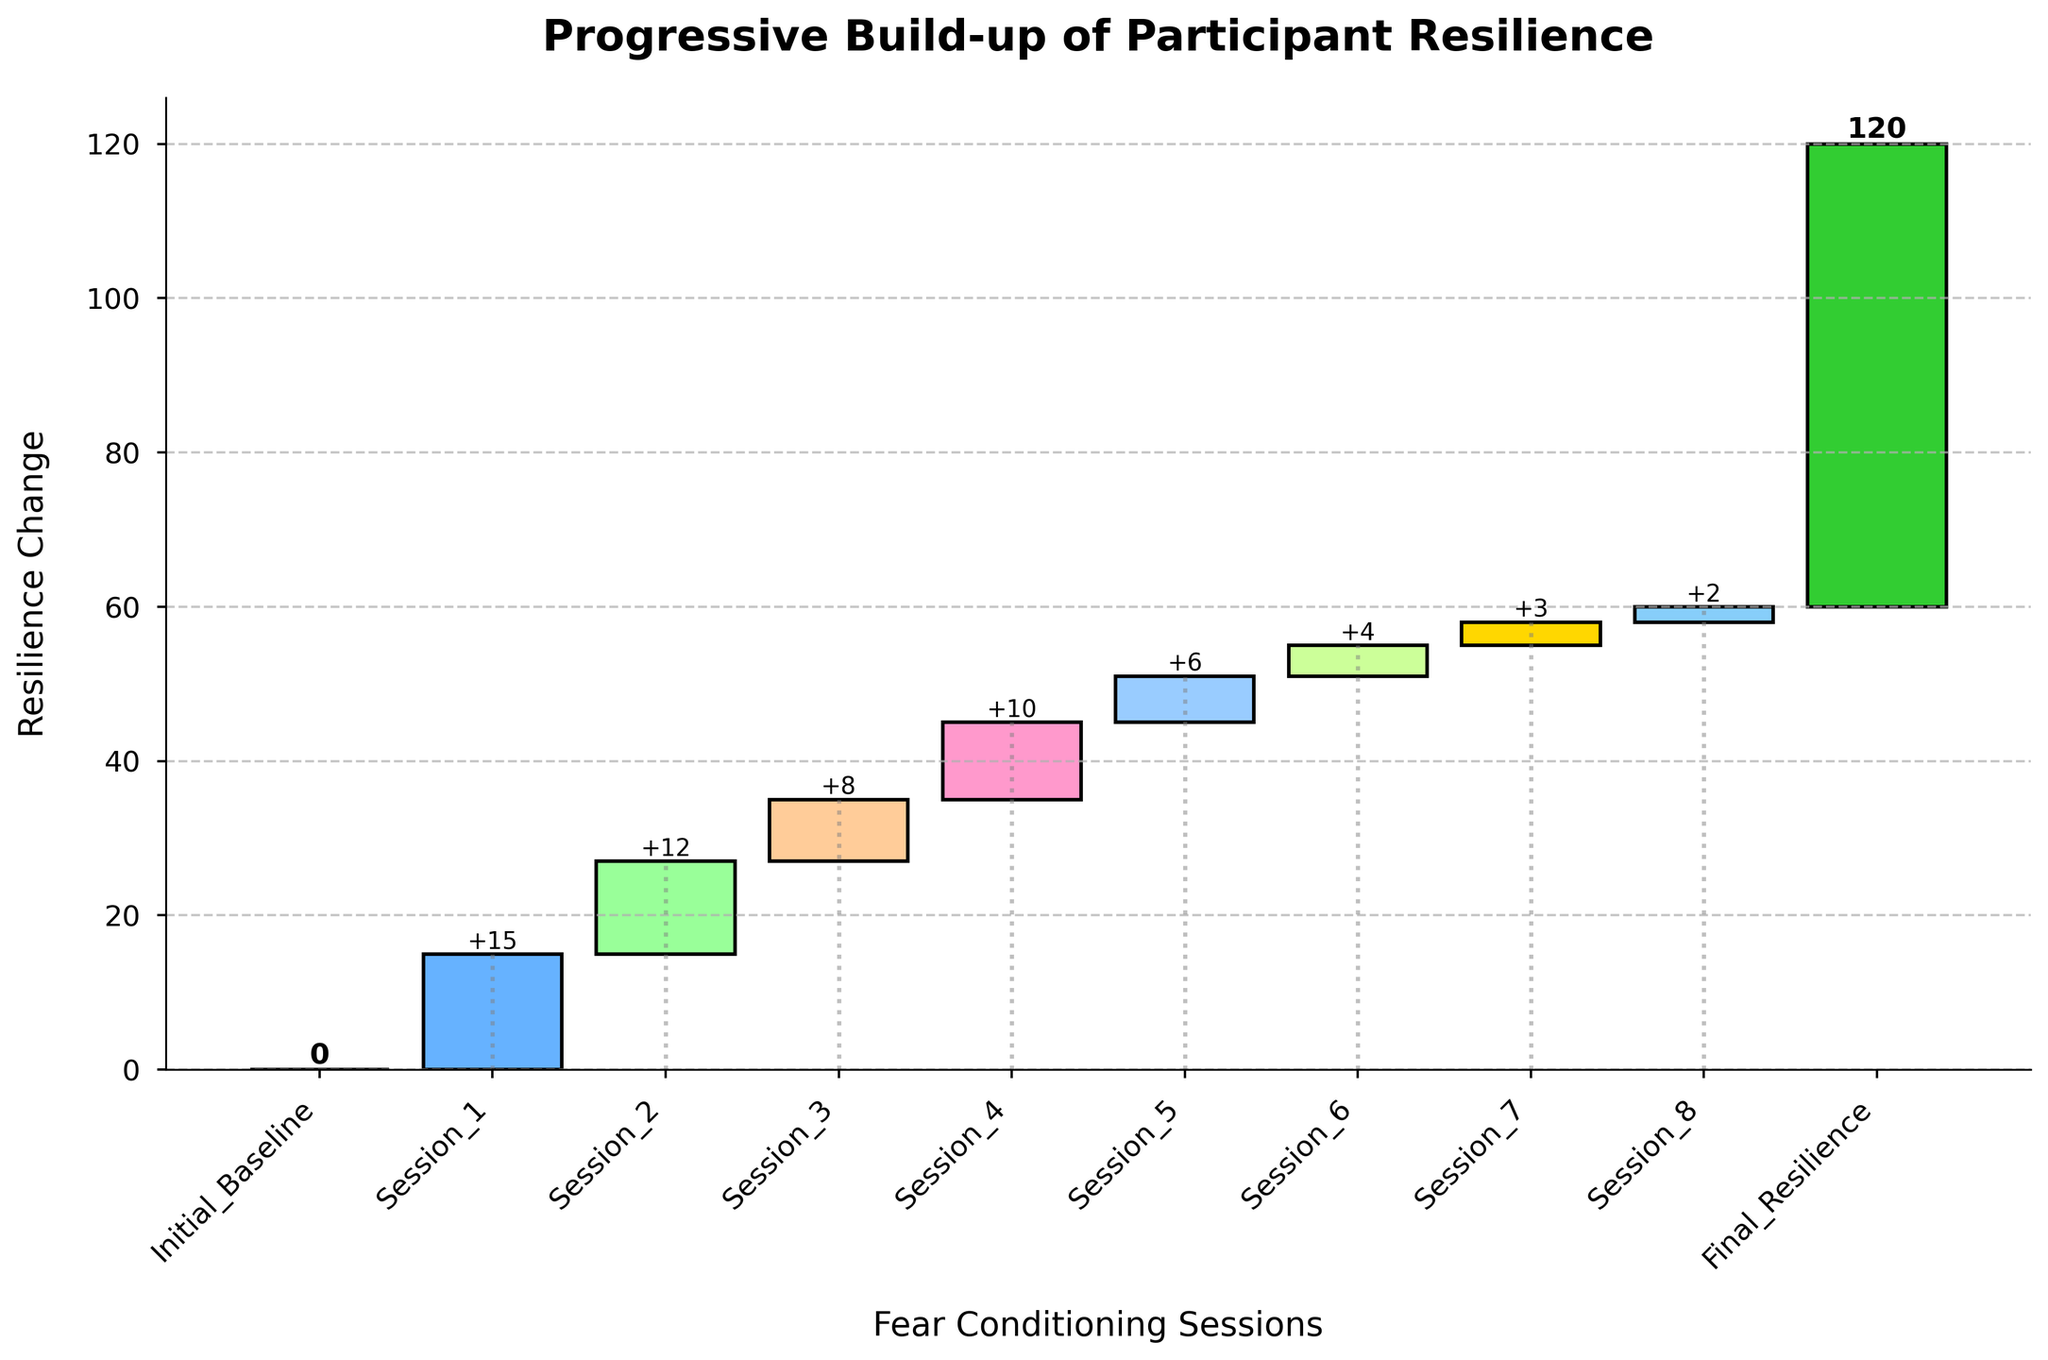What is the title of the chart? The title is located at the top of the chart and is clearly written in bold letters.
Answer: Progressive Build-up of Participant Resilience How many fear conditioning sessions are represented in the chart? Count the number of bars on the x-axis representing different sessions, excluding the initial baseline and final resilience bars.
Answer: 8 Which session shows the highest resilience change? Compare the heights of the bars for each session after the initial baseline to see which one is the tallest.
Answer: Session 1 What is the cumulative resilience after Session 5? Add the resilience change values starting from the initial baseline up to Session 5. The sum is 0 + 15 + 12 + 8 + 10 + 6 = 51.
Answer: 51 Between which two sessions is the smallest increase in resilience observed? Look for the smallest difference in values between consecutive bars after the initial baseline by examining the numerical labels.
Answer: Session 7 and Session 8 What is the final resilience of the participant? Refer to the numerical label on the last bar, which represents the final resilience.
Answer: 60 How does the resilience change from the initial baseline to the final resilience? Calculate the change by subtracting the initial baseline value from the final resilience value: 60 - 0.
Answer: 60 Which sessions had a resilience change larger than 10? Identify bars with numerical labels greater than 10. These are Session 1 and Session 2.
Answer: Session 1 and Session 2 What is the total resilience change over all fear conditioning sessions? Sum all resilience changes after the initial baseline: 15 + 12 + 8 + 10 + 6 + 4 + 3 + 2 = 60.
Answer: 60 